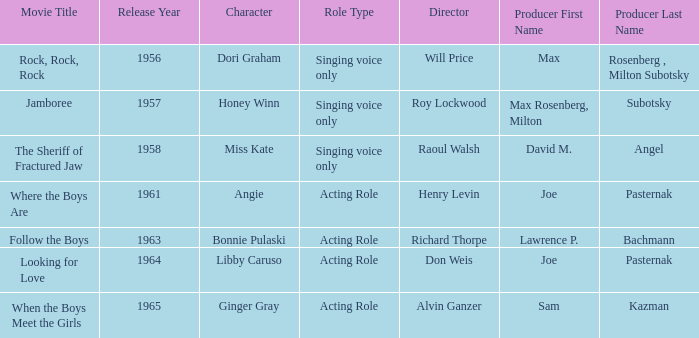Write the full table. {'header': ['Movie Title', 'Release Year', 'Character', 'Role Type', 'Director', 'Producer First Name', 'Producer Last Name'], 'rows': [['Rock, Rock, Rock', '1956', 'Dori Graham', 'Singing voice only', 'Will Price', 'Max', 'Rosenberg , Milton Subotsky'], ['Jamboree', '1957', 'Honey Winn', 'Singing voice only', 'Roy Lockwood', 'Max Rosenberg, Milton', 'Subotsky'], ['The Sheriff of Fractured Jaw', '1958', 'Miss Kate', 'Singing voice only', 'Raoul Walsh', 'David M.', 'Angel'], ['Where the Boys Are', '1961', 'Angie', 'Acting Role', 'Henry Levin', 'Joe', 'Pasternak'], ['Follow the Boys', '1963', 'Bonnie Pulaski', 'Acting Role', 'Richard Thorpe', 'Lawrence P.', 'Bachmann'], ['Looking for Love', '1964', 'Libby Caruso', 'Acting Role', 'Don Weis', 'Joe', 'Pasternak'], ['When the Boys Meet the Girls', '1965', 'Ginger Gray', 'Acting Role', 'Alvin Ganzer', 'Sam', 'Kazman']]} What movie was made in 1957? Jamboree. 